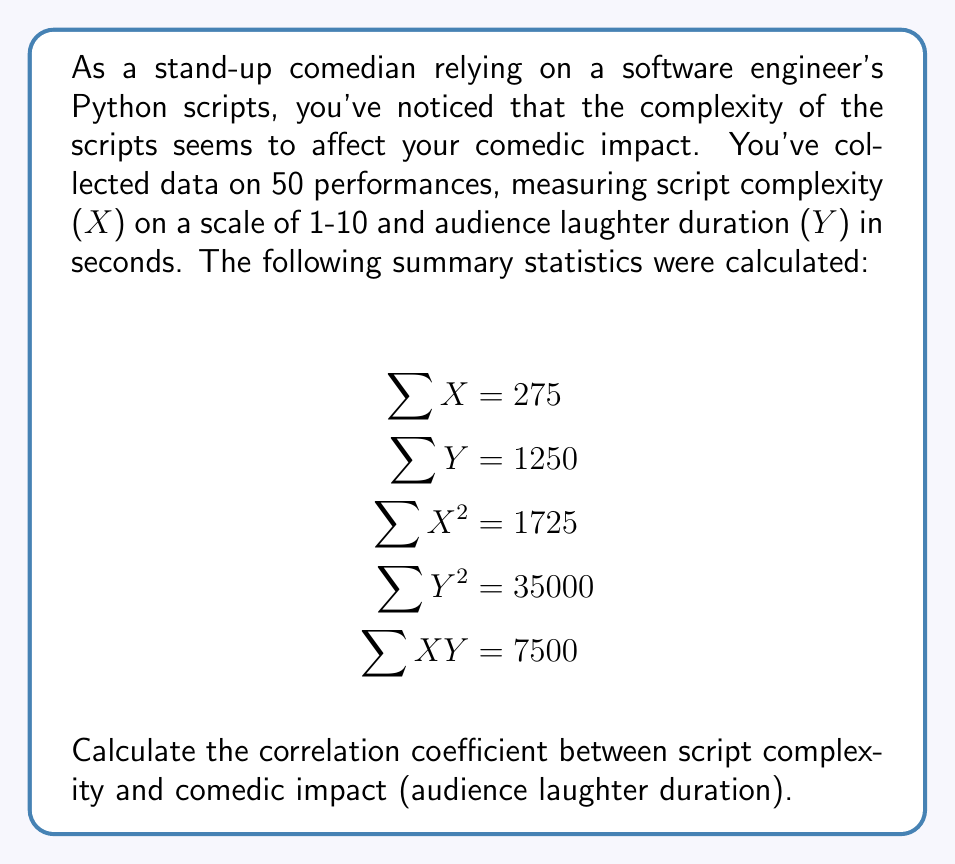Show me your answer to this math problem. To calculate the correlation coefficient, we'll use the formula:

$$r = \frac{n\sum XY - \sum X \sum Y}{\sqrt{[n\sum X^2 - (\sum X)^2][n\sum Y^2 - (\sum Y)^2]}}$$

Where $n$ is the number of data points (50 in this case).

Step 1: Calculate $n\sum XY$
$50 \times 7500 = 375000$

Step 2: Calculate $\sum X \sum Y$
$275 \times 1250 = 343750$

Step 3: Calculate the numerator
$375000 - 343750 = 31250$

Step 4: Calculate $n\sum X^2$
$50 \times 1725 = 86250$

Step 5: Calculate $(\sum X)^2$
$275^2 = 75625$

Step 6: Calculate $n\sum Y^2$
$50 \times 35000 = 1750000$

Step 7: Calculate $(\sum Y)^2$
$1250^2 = 1562500$

Step 8: Calculate the denominator
$\sqrt{(86250 - 75625)(1750000 - 1562500)} = \sqrt{10625 \times 187500} = \sqrt{1992187500} = 44633.18$

Step 9: Calculate the correlation coefficient
$r = \frac{31250}{44633.18} = 0.7002$
Answer: $r \approx 0.7002$ 